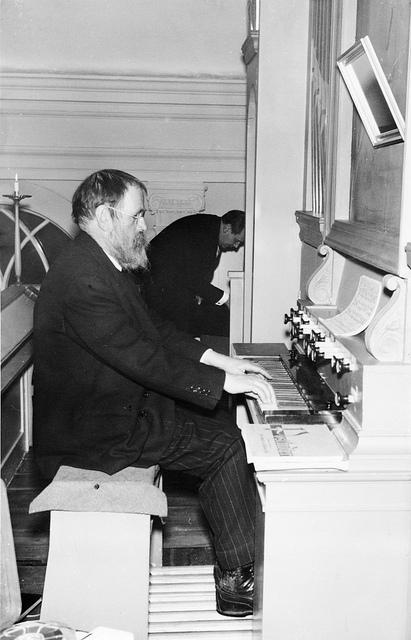Does the man have a beard?
Concise answer only. Yes. What is the man playing?
Concise answer only. Piano. Is the man wearing shoes?
Concise answer only. Yes. What is on the wall above the piano?
Write a very short answer. Picture. 